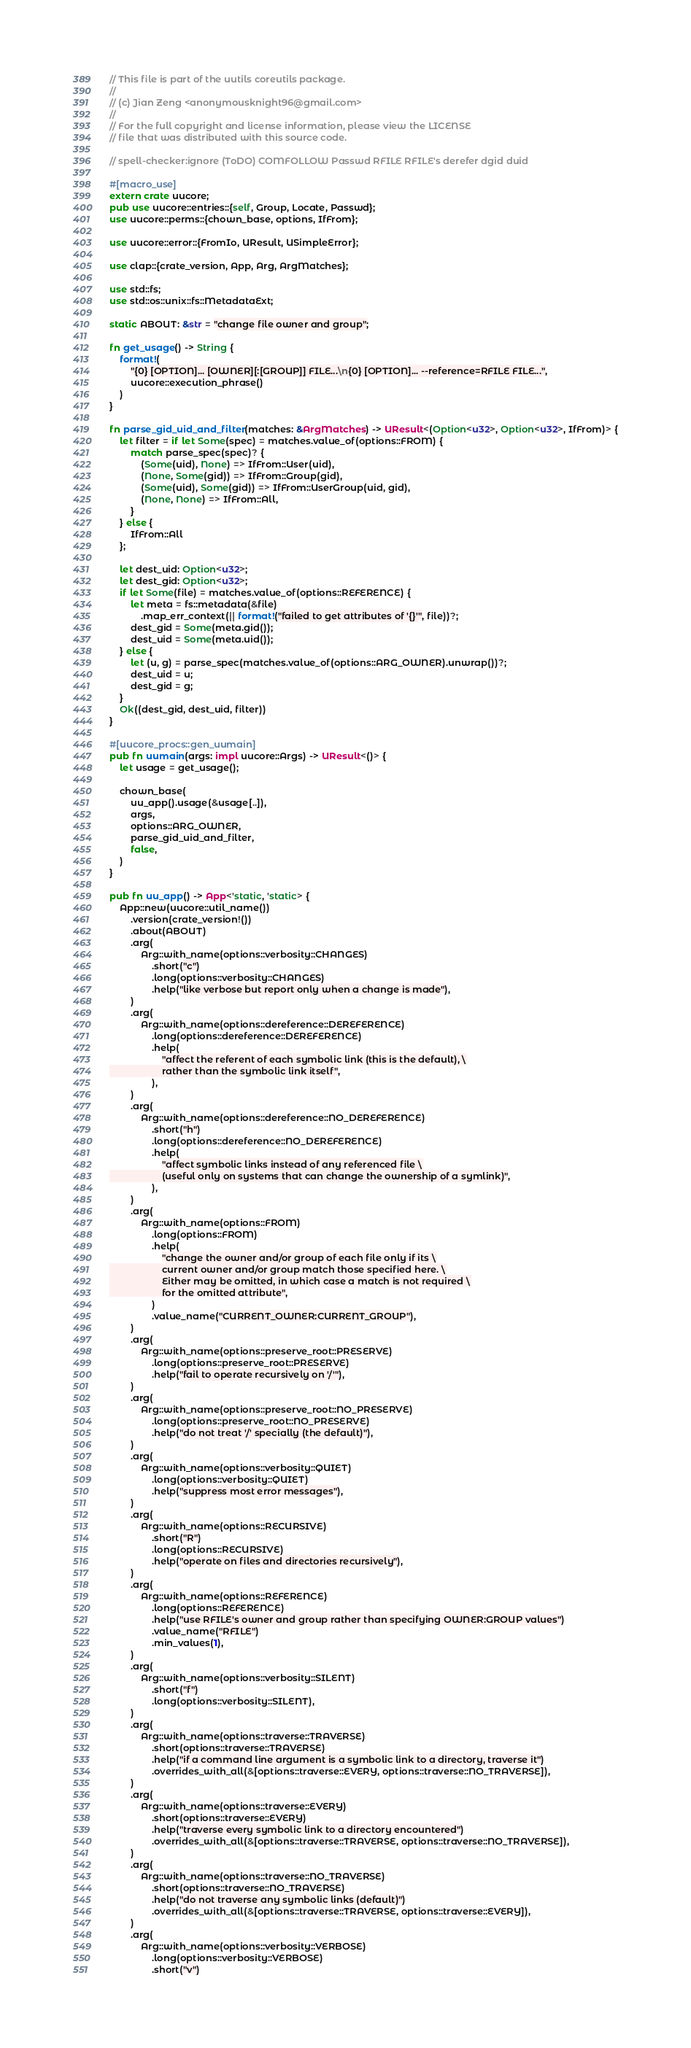Convert code to text. <code><loc_0><loc_0><loc_500><loc_500><_Rust_>// This file is part of the uutils coreutils package.
//
// (c) Jian Zeng <anonymousknight96@gmail.com>
//
// For the full copyright and license information, please view the LICENSE
// file that was distributed with this source code.

// spell-checker:ignore (ToDO) COMFOLLOW Passwd RFILE RFILE's derefer dgid duid

#[macro_use]
extern crate uucore;
pub use uucore::entries::{self, Group, Locate, Passwd};
use uucore::perms::{chown_base, options, IfFrom};

use uucore::error::{FromIo, UResult, USimpleError};

use clap::{crate_version, App, Arg, ArgMatches};

use std::fs;
use std::os::unix::fs::MetadataExt;

static ABOUT: &str = "change file owner and group";

fn get_usage() -> String {
    format!(
        "{0} [OPTION]... [OWNER][:[GROUP]] FILE...\n{0} [OPTION]... --reference=RFILE FILE...",
        uucore::execution_phrase()
    )
}

fn parse_gid_uid_and_filter(matches: &ArgMatches) -> UResult<(Option<u32>, Option<u32>, IfFrom)> {
    let filter = if let Some(spec) = matches.value_of(options::FROM) {
        match parse_spec(spec)? {
            (Some(uid), None) => IfFrom::User(uid),
            (None, Some(gid)) => IfFrom::Group(gid),
            (Some(uid), Some(gid)) => IfFrom::UserGroup(uid, gid),
            (None, None) => IfFrom::All,
        }
    } else {
        IfFrom::All
    };

    let dest_uid: Option<u32>;
    let dest_gid: Option<u32>;
    if let Some(file) = matches.value_of(options::REFERENCE) {
        let meta = fs::metadata(&file)
            .map_err_context(|| format!("failed to get attributes of '{}'", file))?;
        dest_gid = Some(meta.gid());
        dest_uid = Some(meta.uid());
    } else {
        let (u, g) = parse_spec(matches.value_of(options::ARG_OWNER).unwrap())?;
        dest_uid = u;
        dest_gid = g;
    }
    Ok((dest_gid, dest_uid, filter))
}

#[uucore_procs::gen_uumain]
pub fn uumain(args: impl uucore::Args) -> UResult<()> {
    let usage = get_usage();

    chown_base(
        uu_app().usage(&usage[..]),
        args,
        options::ARG_OWNER,
        parse_gid_uid_and_filter,
        false,
    )
}

pub fn uu_app() -> App<'static, 'static> {
    App::new(uucore::util_name())
        .version(crate_version!())
        .about(ABOUT)
        .arg(
            Arg::with_name(options::verbosity::CHANGES)
                .short("c")
                .long(options::verbosity::CHANGES)
                .help("like verbose but report only when a change is made"),
        )
        .arg(
            Arg::with_name(options::dereference::DEREFERENCE)
                .long(options::dereference::DEREFERENCE)
                .help(
                    "affect the referent of each symbolic link (this is the default), \
                    rather than the symbolic link itself",
                ),
        )
        .arg(
            Arg::with_name(options::dereference::NO_DEREFERENCE)
                .short("h")
                .long(options::dereference::NO_DEREFERENCE)
                .help(
                    "affect symbolic links instead of any referenced file \
                    (useful only on systems that can change the ownership of a symlink)",
                ),
        )
        .arg(
            Arg::with_name(options::FROM)
                .long(options::FROM)
                .help(
                    "change the owner and/or group of each file only if its \
                    current owner and/or group match those specified here. \
                    Either may be omitted, in which case a match is not required \
                    for the omitted attribute",
                )
                .value_name("CURRENT_OWNER:CURRENT_GROUP"),
        )
        .arg(
            Arg::with_name(options::preserve_root::PRESERVE)
                .long(options::preserve_root::PRESERVE)
                .help("fail to operate recursively on '/'"),
        )
        .arg(
            Arg::with_name(options::preserve_root::NO_PRESERVE)
                .long(options::preserve_root::NO_PRESERVE)
                .help("do not treat '/' specially (the default)"),
        )
        .arg(
            Arg::with_name(options::verbosity::QUIET)
                .long(options::verbosity::QUIET)
                .help("suppress most error messages"),
        )
        .arg(
            Arg::with_name(options::RECURSIVE)
                .short("R")
                .long(options::RECURSIVE)
                .help("operate on files and directories recursively"),
        )
        .arg(
            Arg::with_name(options::REFERENCE)
                .long(options::REFERENCE)
                .help("use RFILE's owner and group rather than specifying OWNER:GROUP values")
                .value_name("RFILE")
                .min_values(1),
        )
        .arg(
            Arg::with_name(options::verbosity::SILENT)
                .short("f")
                .long(options::verbosity::SILENT),
        )
        .arg(
            Arg::with_name(options::traverse::TRAVERSE)
                .short(options::traverse::TRAVERSE)
                .help("if a command line argument is a symbolic link to a directory, traverse it")
                .overrides_with_all(&[options::traverse::EVERY, options::traverse::NO_TRAVERSE]),
        )
        .arg(
            Arg::with_name(options::traverse::EVERY)
                .short(options::traverse::EVERY)
                .help("traverse every symbolic link to a directory encountered")
                .overrides_with_all(&[options::traverse::TRAVERSE, options::traverse::NO_TRAVERSE]),
        )
        .arg(
            Arg::with_name(options::traverse::NO_TRAVERSE)
                .short(options::traverse::NO_TRAVERSE)
                .help("do not traverse any symbolic links (default)")
                .overrides_with_all(&[options::traverse::TRAVERSE, options::traverse::EVERY]),
        )
        .arg(
            Arg::with_name(options::verbosity::VERBOSE)
                .long(options::verbosity::VERBOSE)
                .short("v")</code> 